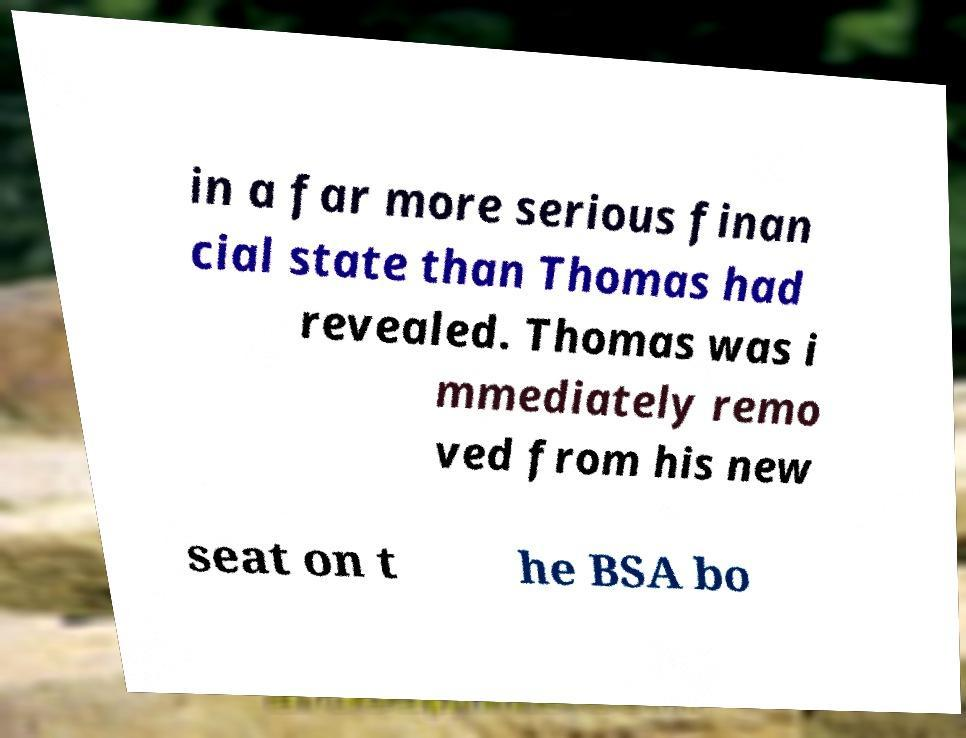I need the written content from this picture converted into text. Can you do that? in a far more serious finan cial state than Thomas had revealed. Thomas was i mmediately remo ved from his new seat on t he BSA bo 